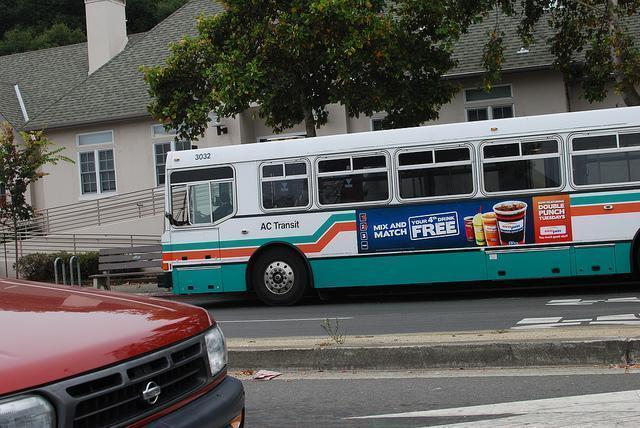What day is Double Punch?
Select the correct answer and articulate reasoning with the following format: 'Answer: answer
Rationale: rationale.'
Options: Wednesday, friday, monday, tuesday. Answer: tuesday.
Rationale: The day is tuesday. 